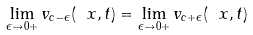<formula> <loc_0><loc_0><loc_500><loc_500>\lim _ { \epsilon \to 0 + } v _ { c - \epsilon } ( \ x , t ) = \lim _ { \epsilon \to 0 + } v _ { c + \epsilon } ( \ x , t )</formula> 